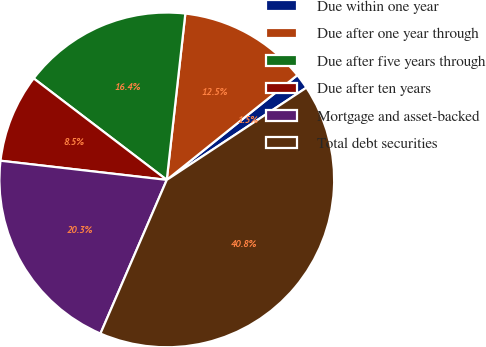<chart> <loc_0><loc_0><loc_500><loc_500><pie_chart><fcel>Due within one year<fcel>Due after one year through<fcel>Due after five years through<fcel>Due after ten years<fcel>Mortgage and asset-backed<fcel>Total debt securities<nl><fcel>1.47%<fcel>12.47%<fcel>16.4%<fcel>8.54%<fcel>20.34%<fcel>40.77%<nl></chart> 